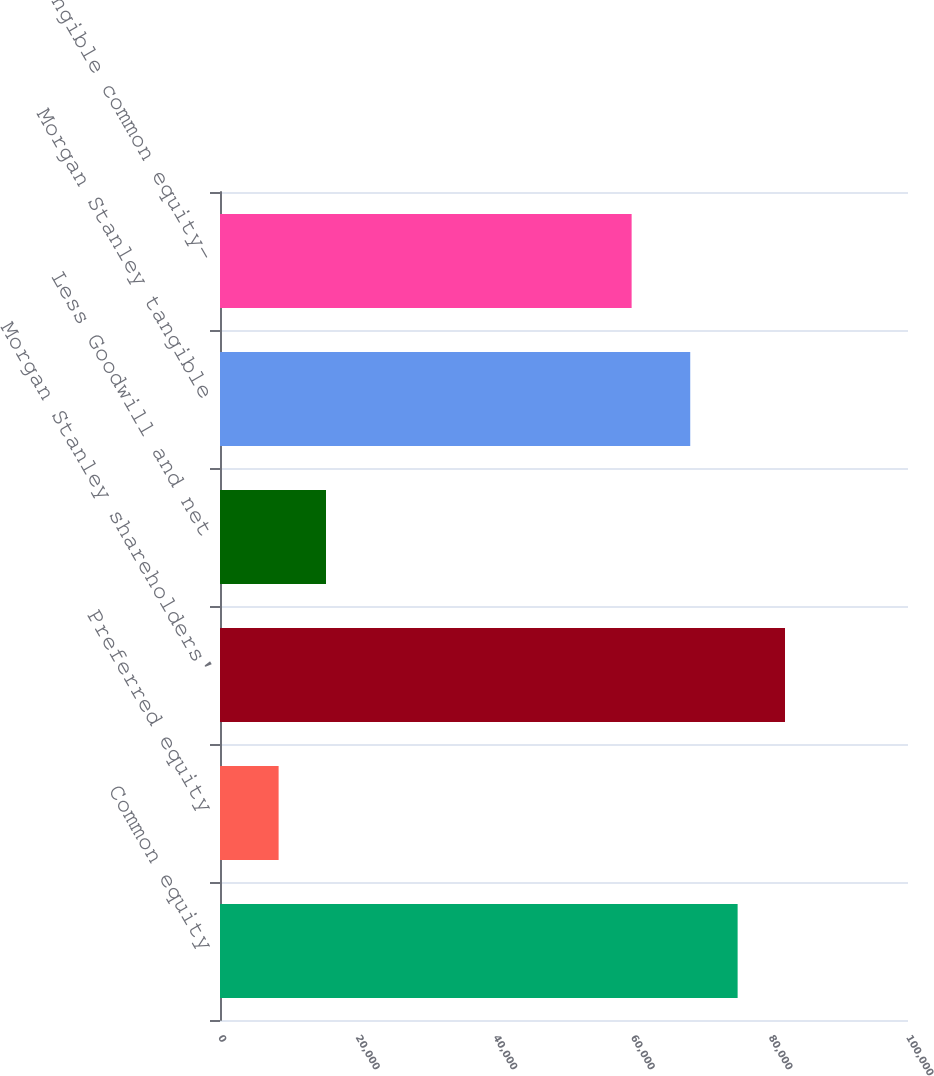Convert chart. <chart><loc_0><loc_0><loc_500><loc_500><bar_chart><fcel>Common equity<fcel>Preferred equity<fcel>Morgan Stanley shareholders'<fcel>Less Goodwill and net<fcel>Morgan Stanley tangible<fcel>Tangible common equity-<nl><fcel>75236.1<fcel>8520<fcel>82123.2<fcel>15407.1<fcel>68349<fcel>59829<nl></chart> 